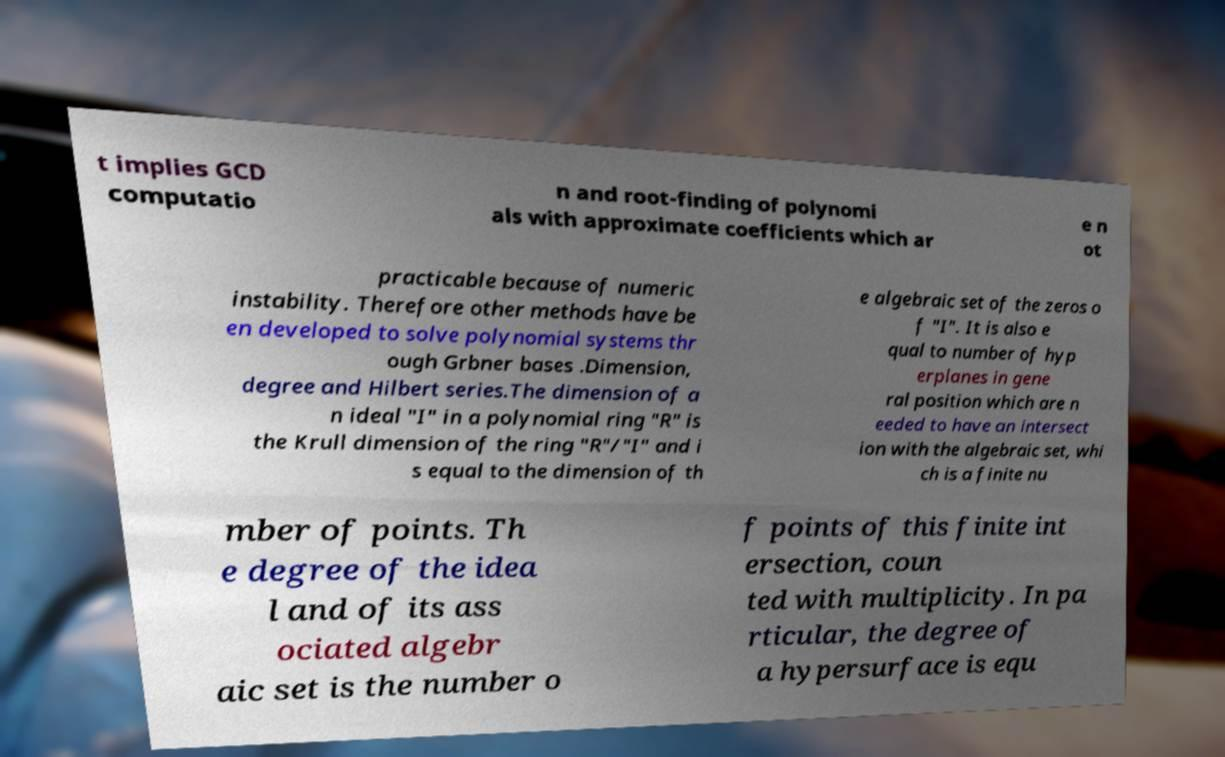Can you read and provide the text displayed in the image?This photo seems to have some interesting text. Can you extract and type it out for me? t implies GCD computatio n and root-finding of polynomi als with approximate coefficients which ar e n ot practicable because of numeric instability. Therefore other methods have be en developed to solve polynomial systems thr ough Grbner bases .Dimension, degree and Hilbert series.The dimension of a n ideal "I" in a polynomial ring "R" is the Krull dimension of the ring "R"/"I" and i s equal to the dimension of th e algebraic set of the zeros o f "I". It is also e qual to number of hyp erplanes in gene ral position which are n eeded to have an intersect ion with the algebraic set, whi ch is a finite nu mber of points. Th e degree of the idea l and of its ass ociated algebr aic set is the number o f points of this finite int ersection, coun ted with multiplicity. In pa rticular, the degree of a hypersurface is equ 